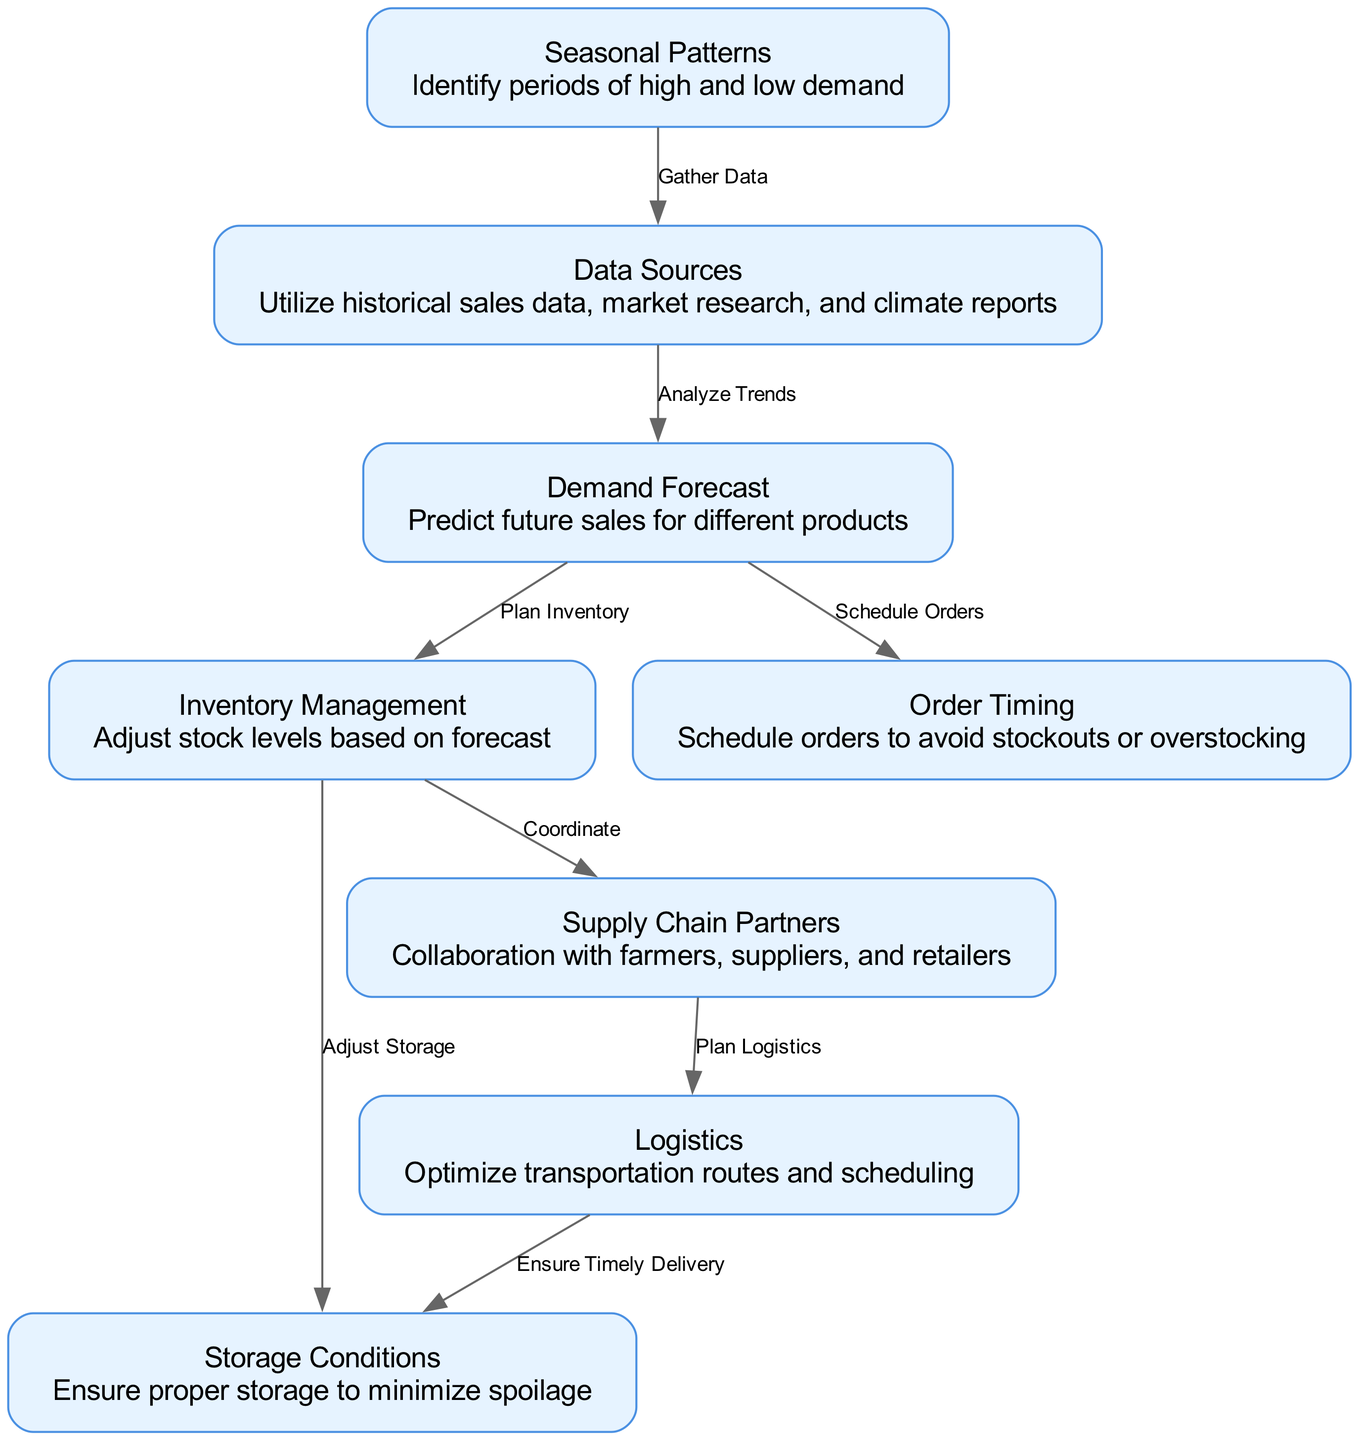What's the total number of nodes in the diagram? The diagram has a total of 8 nodes: "Seasonal Patterns," "Data Sources," "Demand Forecast," "Inventory Management," "Order Timing," "Storage Conditions," "Supply Chain Partners," and "Logistics."
Answer: 8 What is the label of the node connected to "Data Sources"? "Data Sources" is connected to "Demand Forecast." Each edge in the diagram showcases the flow of information, and here it shows that data from "Data Sources" is analyzed to predict future sales.
Answer: Demand Forecast Which node represents the action of minimizing spoilage? The action of minimizing spoilage is represented by the node "Storage Conditions," which focuses on ensuring proper storage to preserve perishable goods.
Answer: Storage Conditions Which nodes are directly connected to "Demand Forecast"? "Demand Forecast" connects directly to "Inventory Management" and "Order Timing," indicating that the forecast influences both inventory levels and order schedules.
Answer: Inventory Management, Order Timing What is the primary flow starting from "Seasonal Patterns"? The primary flow starts from "Seasonal Patterns," which gathers data from "Data Sources," then leads to "Demand Forecast," which further impacts both "Inventory Management" and "Order Timing."
Answer: Demand Forecast What type of relationship exists between "Supply Chain Partners" and "Logistics"? The relationship between "Supply Chain Partners" and "Logistics" is one of planning, as the collaboration with these partners helps to optimize transportation routes and scheduling.
Answer: Plan Logistics How many edges are leading out from the "Inventory Management" node? There are two edges leading out from the "Inventory Management" node: one to "Storage Conditions" and another to "Supply Chain Partners," showcasing its relations to both storage adjustments and coordination with partners.
Answer: 2 What action is associated with the "Order Timing" node? The action associated with the "Order Timing" node is "Schedule Orders," indicating that timing is critical to avoid stockouts or overstocking for perishable goods.
Answer: Schedule Orders What is the flow of actions from "Demand Forecast" to "Logistics"? The flow from "Demand Forecast" first leads to "Inventory Management," and then from "Inventory Management" to "Supply Chain Partners," which subsequently connects to "Logistics." This shows how forecasting affects inventory and logistic planning.
Answer: Inventory Management, Supply Chain Partners, Logistics 